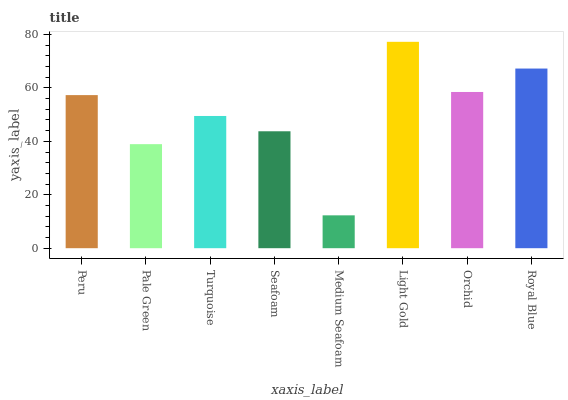Is Medium Seafoam the minimum?
Answer yes or no. Yes. Is Light Gold the maximum?
Answer yes or no. Yes. Is Pale Green the minimum?
Answer yes or no. No. Is Pale Green the maximum?
Answer yes or no. No. Is Peru greater than Pale Green?
Answer yes or no. Yes. Is Pale Green less than Peru?
Answer yes or no. Yes. Is Pale Green greater than Peru?
Answer yes or no. No. Is Peru less than Pale Green?
Answer yes or no. No. Is Peru the high median?
Answer yes or no. Yes. Is Turquoise the low median?
Answer yes or no. Yes. Is Medium Seafoam the high median?
Answer yes or no. No. Is Medium Seafoam the low median?
Answer yes or no. No. 